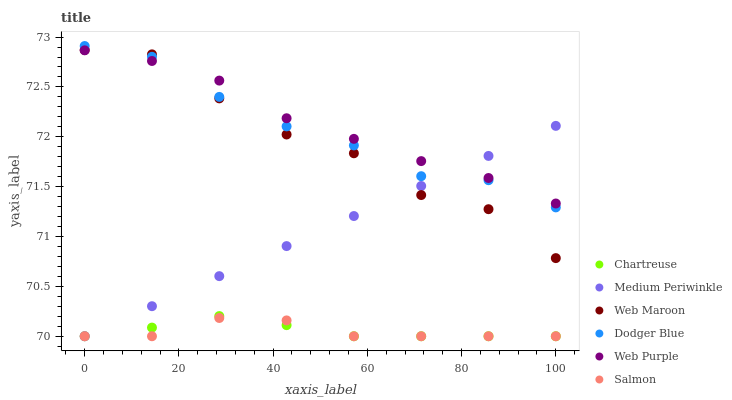Does Salmon have the minimum area under the curve?
Answer yes or no. Yes. Does Web Purple have the maximum area under the curve?
Answer yes or no. Yes. Does Web Maroon have the minimum area under the curve?
Answer yes or no. No. Does Web Maroon have the maximum area under the curve?
Answer yes or no. No. Is Medium Periwinkle the smoothest?
Answer yes or no. Yes. Is Web Maroon the roughest?
Answer yes or no. Yes. Is Web Purple the smoothest?
Answer yes or no. No. Is Web Purple the roughest?
Answer yes or no. No. Does Medium Periwinkle have the lowest value?
Answer yes or no. Yes. Does Web Maroon have the lowest value?
Answer yes or no. No. Does Dodger Blue have the highest value?
Answer yes or no. Yes. Does Web Maroon have the highest value?
Answer yes or no. No. Is Salmon less than Dodger Blue?
Answer yes or no. Yes. Is Web Maroon greater than Chartreuse?
Answer yes or no. Yes. Does Medium Periwinkle intersect Web Purple?
Answer yes or no. Yes. Is Medium Periwinkle less than Web Purple?
Answer yes or no. No. Is Medium Periwinkle greater than Web Purple?
Answer yes or no. No. Does Salmon intersect Dodger Blue?
Answer yes or no. No. 